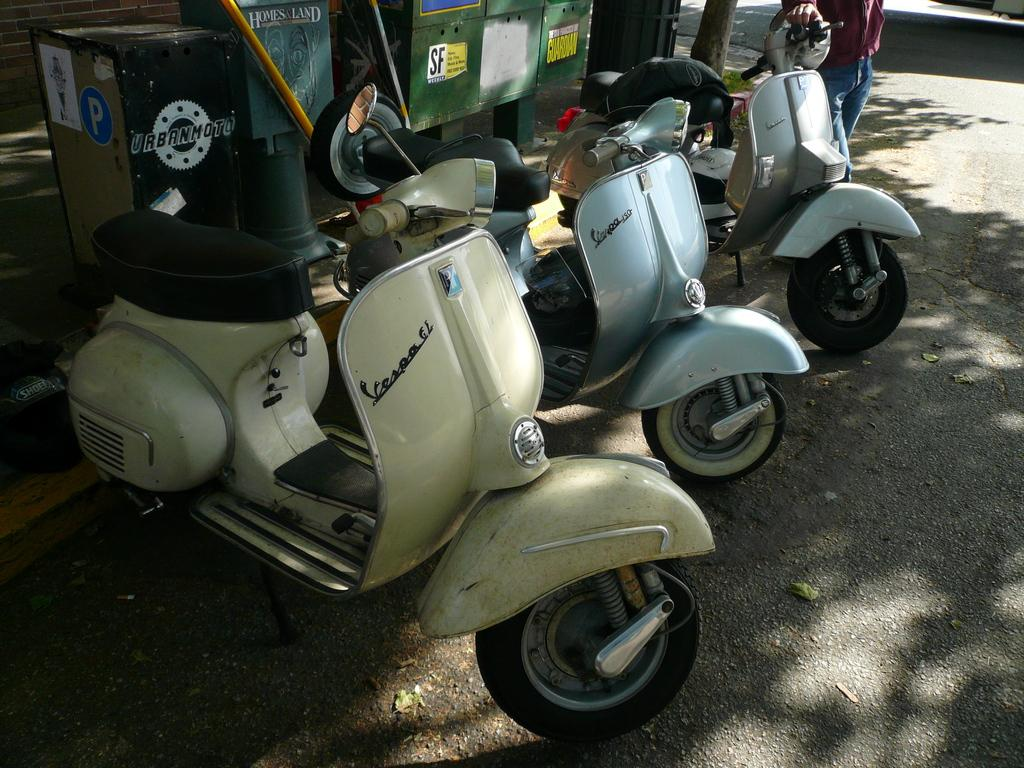What type of vehicles are parked on the road in the image? There are scooters parked on the road in the image. What is the person standing near the scooters doing? The person is standing and holding a scooter. What objects can be seen behind the parked scooters? There are boxes visible at the back. What natural element is present in the image? There is a tree trunk visible in the image. What color is the silver ball that is rolling on the ground in the image? There is no silver ball present in the image; it only features scooters, a person, boxes, and a tree trunk. 